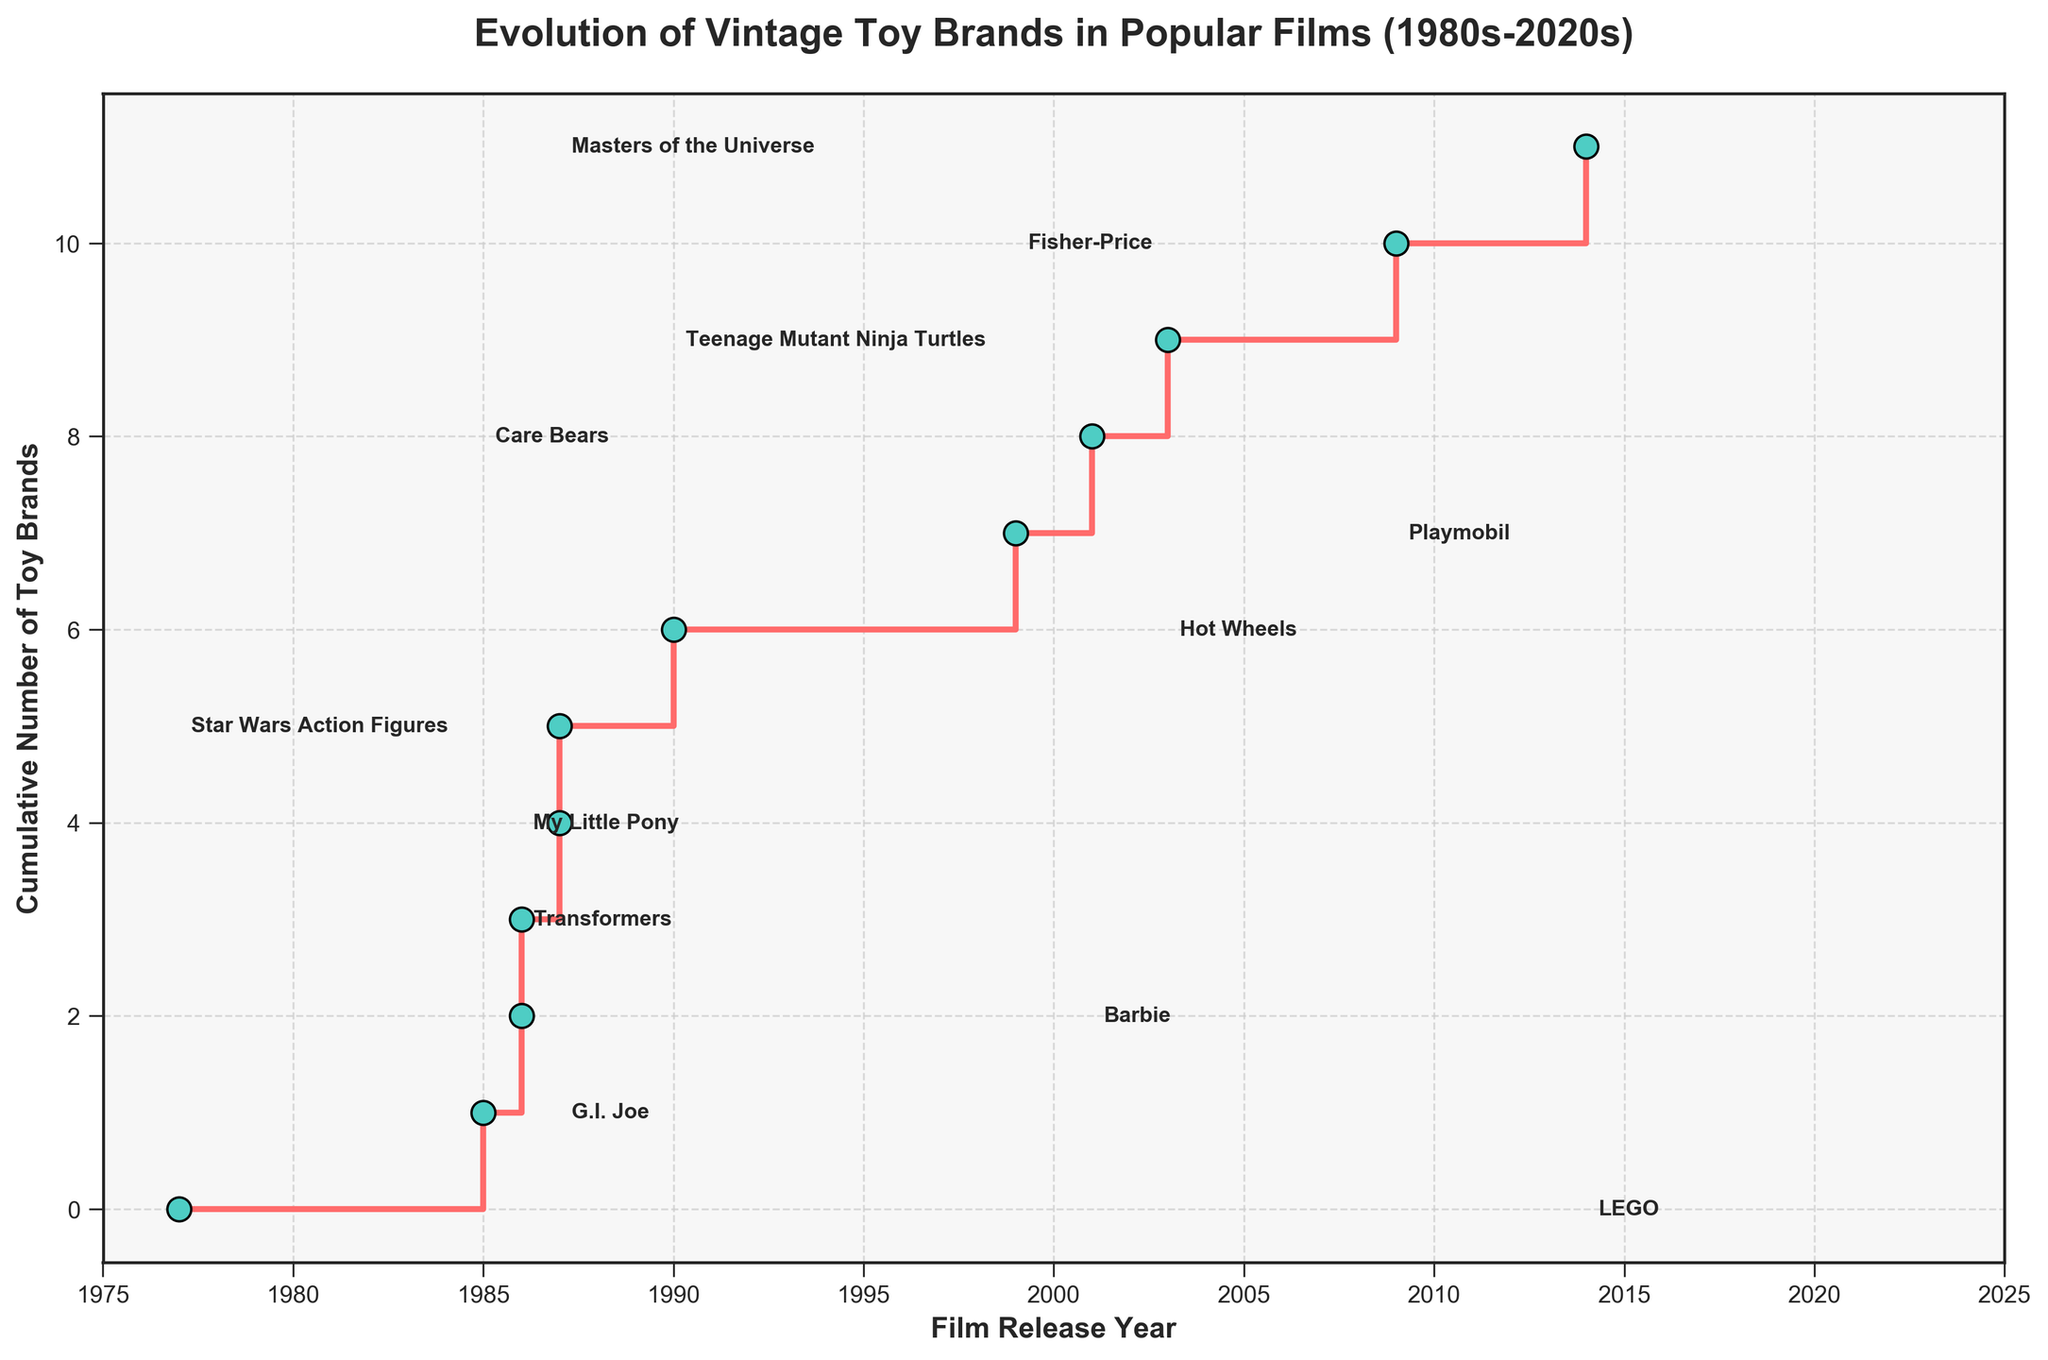What is the title of the plot? The title is displayed prominently at the top of the figure.
Answer: Evolution of Vintage Toy Brands in Popular Films (1980s-2020s) How many toy brands made their cinema debut in the 1980s? By examining the x-axis and the markers, identify which films were released in the 1980s (1980-1989). Count the number of such films.
Answer: 6 Which toy brand had its first major film appearance the earliest? Look for the leftmost data point on the plot and read the corresponding label.
Answer: Star Wars Action Figures In which year did two toy brands make their first major film appearance? Identify the x-axis tick that aligns with two markers and read the corresponding year.
Answer: 1986 How many cumulative toy brands had made their film debut by the year 2000? Identify the step change just before the year 2000 on the x-axis and read the cumulative count on the y-axis at that point.
Answer: 5 